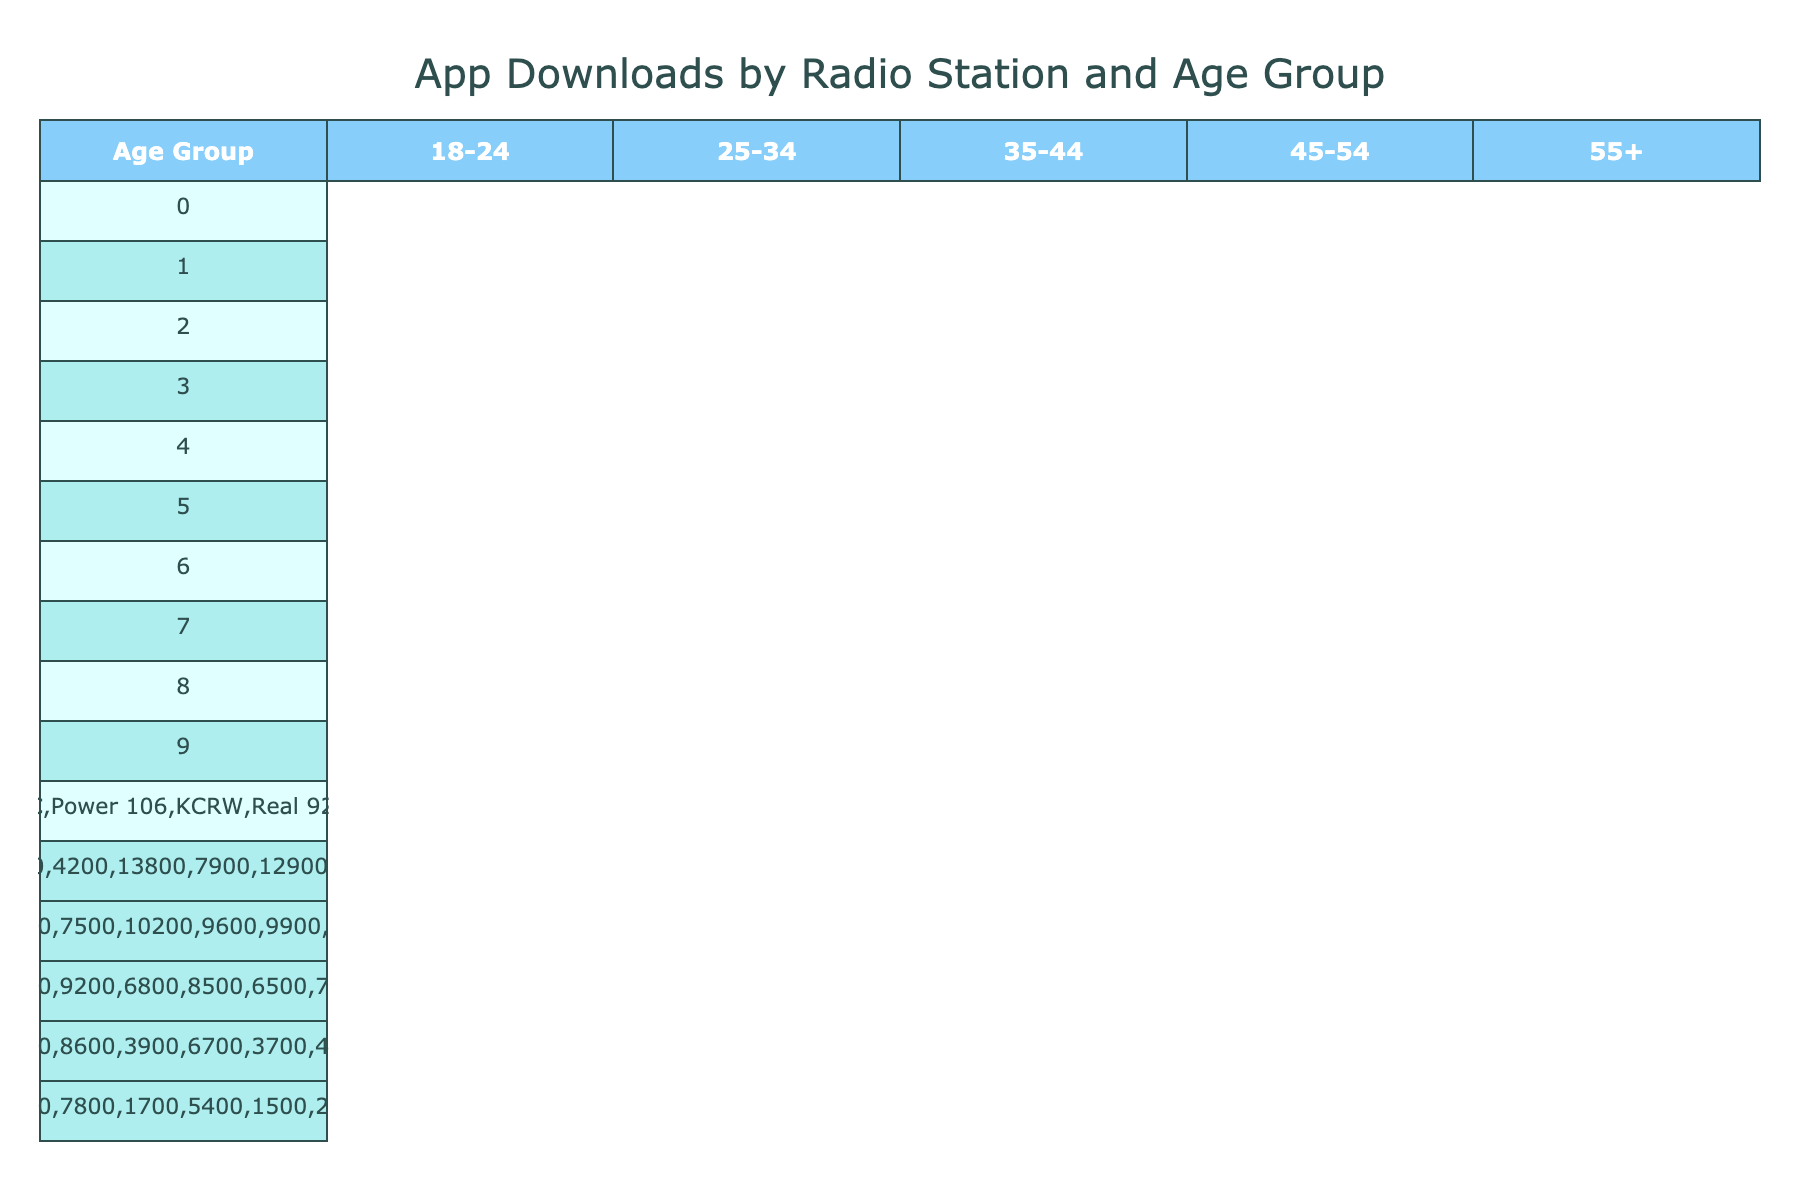What is the total number of downloads for the 25-34 age group across all radio stations? To find the total number of downloads for the 25-34 age group, sum the values for this age group from all radio stations: 9800 (KIIS FM) + 10500 (KROQ) + 8200 (KFI AM 640) + 7500 (KPCC) + 10200 (Power 106) + 9600 (KCRW) + 9900 (Real 92.3) + 9700 (ALT 98.7) + 9300 (KLOS) + 7800 (K-EARTH 101) = 90,700
Answer: 90700 Which radio station had the highest number of downloads for the 18-24 age group? Looking at the data for the 18-24 age group, the values are as follows: KIIS FM (12500), KROQ (11200), KFI AM 640 (5600), KPCC (4200), Power 106 (13800), KCRW (7900), Real 92.3 (12900), ALT 98.7 (10800), KLOS (8200), and K-EARTH 101 (6500). The highest is from Power 106 with 13800 downloads.
Answer: Power 106 What is the average number of downloads for the 45-54 age group across all radio stations? For the 45-54 age group, the downloads are: 4500 (KIIS FM), 5300 (KROQ), 8900 (KFI AM 640), 8600 (KPCC), 3900 (Power 106), 6700 (KCRW), 3700 (Real 92.3), 4800 (ALT 98.7), 7600 (KLOS), and 8200 (K-EARTH 101). Adding these gives a total of 52500, and with 10 data points, the average is 52500/10 = 5250.
Answer: 5250 Is it true that KFI AM 640 has more downloads from the 35-44 age group than KPCC? Checking the values, KFI AM 640 has 9700 downloads while KPCC has 9200 downloads for the 35-44 age group. Since 9700 is greater than 9200, it is true that KFI AM 640 has more downloads.
Answer: True Which age group has the lowest total downloads when summed across all radio stations? To determine the lowest total, calculate the sum for each age group: 18-24: 12500 + 11200 + 5600 + 4200 + 13800 + 7900 + 12900 + 10800 + 8200 + 6500 = 93000; 25-34: 9800 + 10500 + 8200 + 7500 + 10200 + 9600 + 9900 + 9700 + 9300 + 7800 = 90700; 35-44: 7200 + 8100 + 9700 + 9200 + 6800 + 8500 + 6500 + 7400 + 8800 + 8600 = 80000; 45-54: 4500 + 5300 + 8900 + 8600 + 3900 + 6700 + 3700 + 4800 + 7600 + 8200 = 52500; 55+: 2100 + 2800 + 7500 + 7800 + 1700 + 5400 + 1500 + 2400 + 6200 + 7900 = 32000. The lowest total is for the 55+ age group with 32000 downloads.
Answer: 55+ Which radio station has the second highest downloads in the 25-34 age group? From the table, the downloads for the 25-34 age group are as follows: KIIS FM (9800), KROQ (10500), KFI AM 640 (8200), KPCC (7500), Power 106 (10200), KCRW (9600), Real 92.3 (9900), ALT 98.7 (9700), KLOS (9300), and K-EARTH 101 (7800). The highest is KROQ with 10500, and the second highest is Power 106 with 10200.
Answer: Power 106 What are the download numbers for the 55+ age group for KLOS and K-EARTH 101 combined? KLOS has 6200 downloads and K-EARTH 101 has 7900 downloads for the 55+ age group. Adding them gives: 6200 + 7900 = 14100 downloads combined.
Answer: 14100 Which demographic group downloaded the most apps overall across all radio stations? The total downloads for each age group are: 18-24: 93000, 25-34: 90700, 35-44: 80000, 45-54: 52500, and 55+: 32000. The group with the most downloads is 18-24 with 93000.
Answer: 18-24 